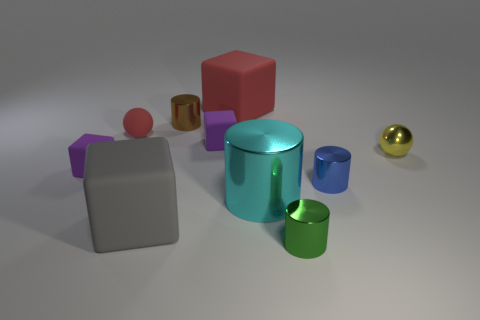What is the size of the matte cube that is the same color as the rubber sphere?
Provide a succinct answer. Large. The large matte thing that is the same color as the small rubber ball is what shape?
Keep it short and to the point. Cube. Is there anything else that has the same color as the big metallic cylinder?
Make the answer very short. No. There is a ball that is on the left side of the green cylinder; does it have the same size as the metal thing that is on the right side of the tiny blue cylinder?
Keep it short and to the point. Yes. Is the number of matte things on the right side of the large gray thing the same as the number of tiny metal cylinders right of the cyan cylinder?
Keep it short and to the point. Yes. There is a red sphere; is it the same size as the metallic cylinder right of the green metal object?
Make the answer very short. Yes. There is a large rubber object that is on the right side of the brown metal cylinder; are there any tiny purple objects that are behind it?
Offer a terse response. No. Is there a small red object of the same shape as the big shiny object?
Your answer should be compact. No. What number of metallic cylinders are behind the metallic object in front of the large thing that is in front of the large cyan cylinder?
Make the answer very short. 3. Does the large metallic object have the same color as the big cube behind the yellow metal sphere?
Offer a terse response. No. 